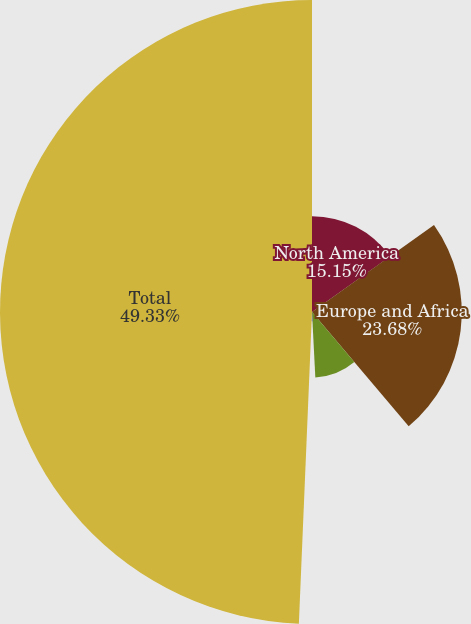<chart> <loc_0><loc_0><loc_500><loc_500><pie_chart><fcel>North America<fcel>Europe and Africa<fcel>Asia-Pacific<fcel>South America<fcel>Total<nl><fcel>15.15%<fcel>23.68%<fcel>10.36%<fcel>1.48%<fcel>49.33%<nl></chart> 